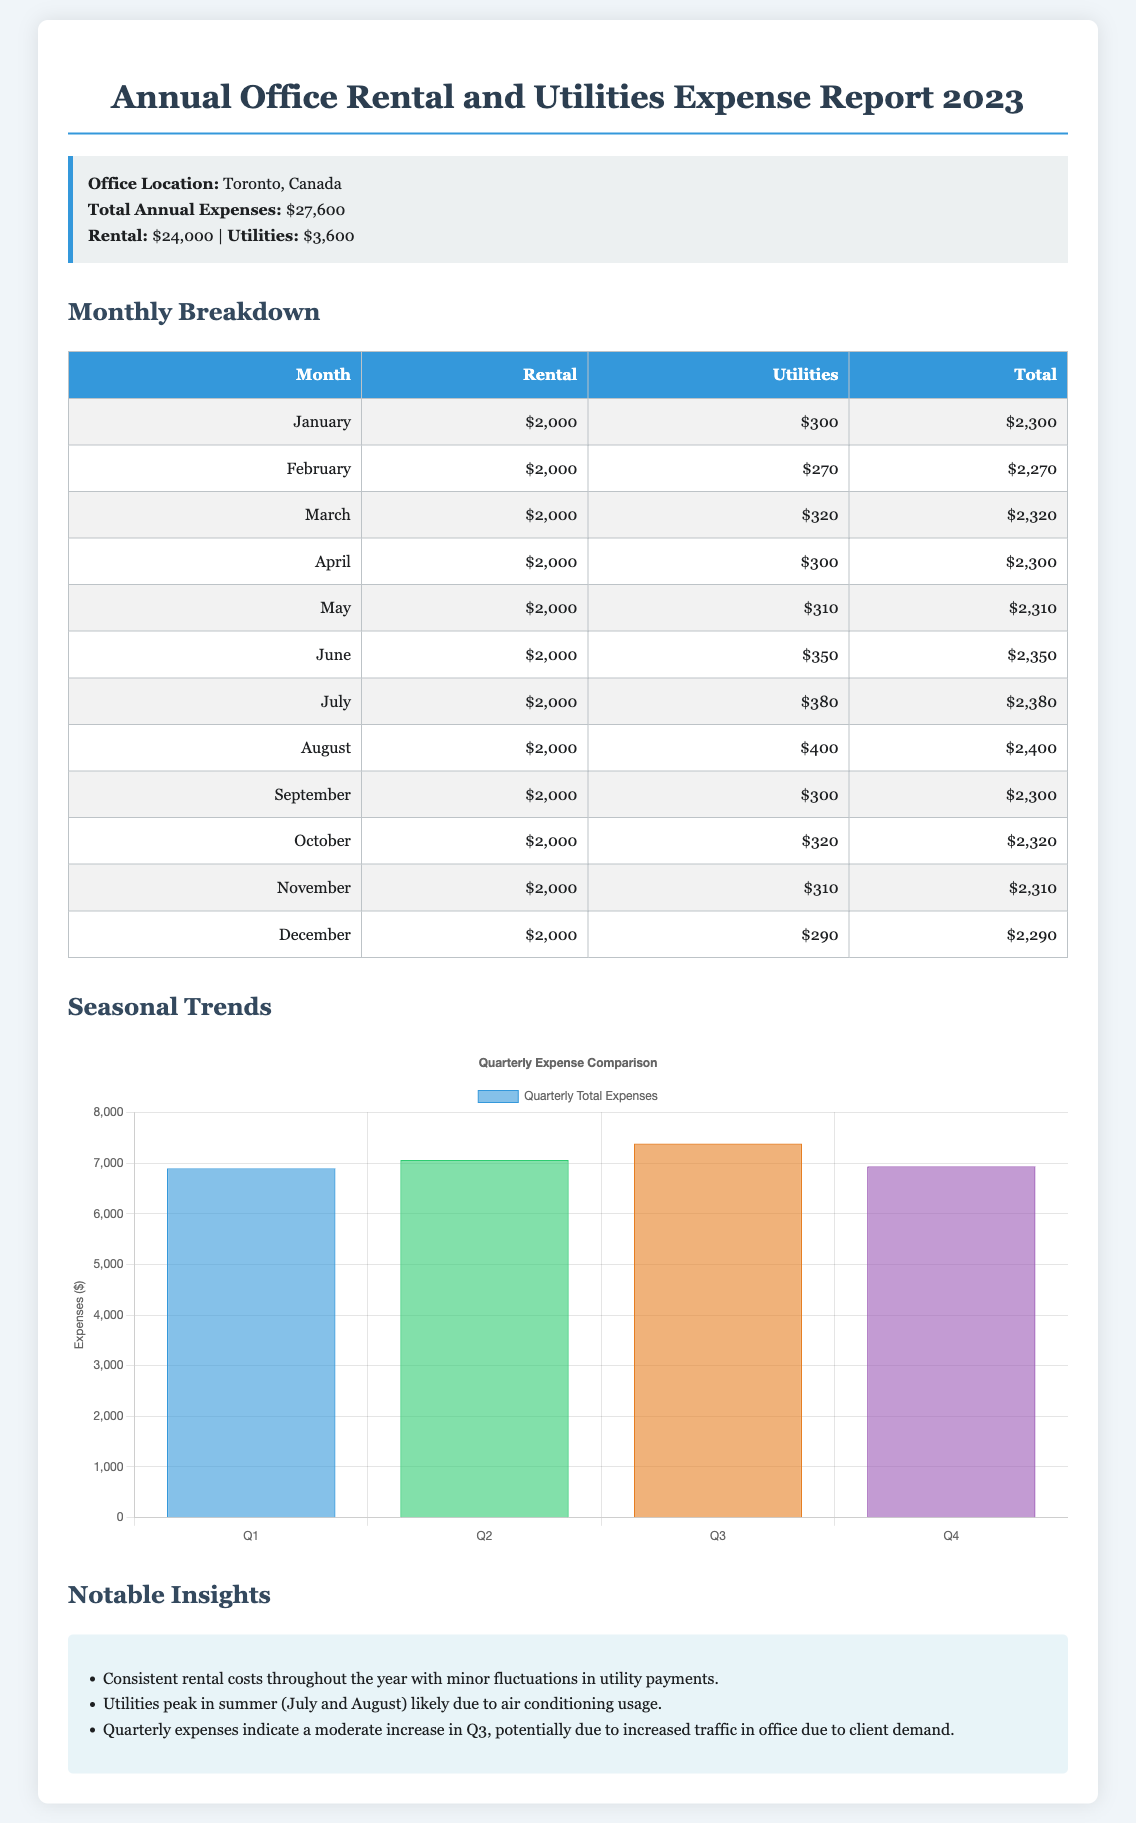What is the total annual expense? The total annual expense is stated clearly in the summary section of the document.
Answer: $27,600 What are the total utilities expenses for the year? The total utilities expenses can be found in the summary section of the document.
Answer: $3,600 In which month did the highest utility expense occur? The monthly breakdown shows the utility expenses, with the highest recorded in August.
Answer: August How much was spent on rental in December? The monthly breakdown table lists the rental expense for December specifically.
Answer: $2,000 What is the total expense in Q1? The quarterly total expenses are provided in the chart, which shows Q1's total.
Answer: $6,890 What month had the lowest utility expense? The monthly table indicates that February had the lowest utility expense amount.
Answer: February Which quarter had the highest total expenses? The quarterly chart shows the expenses for each quarter, identifying the highest.
Answer: Q3 How much did the utilities cost in May? The monthly table details the utility expenses for each month, including May.
Answer: $310 What trend is observed in utility costs during summer months? The insights section notes seasonal trends in utility expenses during summer.
Answer: Peak in summer 